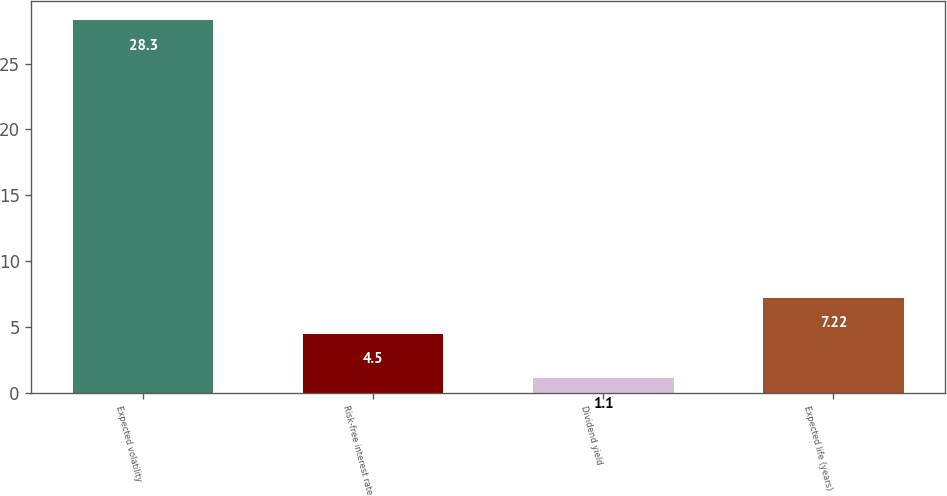<chart> <loc_0><loc_0><loc_500><loc_500><bar_chart><fcel>Expected volatility<fcel>Risk-free interest rate<fcel>Dividend yield<fcel>Expected life (years)<nl><fcel>28.3<fcel>4.5<fcel>1.1<fcel>7.22<nl></chart> 